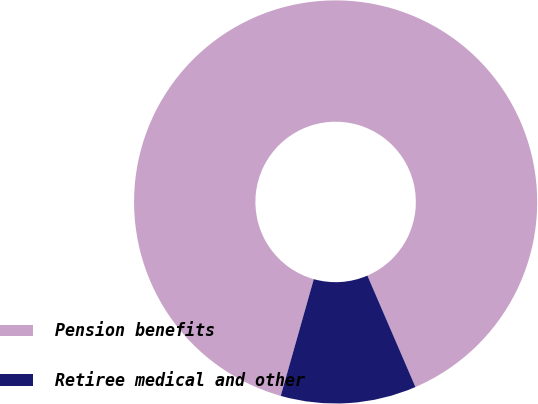<chart> <loc_0><loc_0><loc_500><loc_500><pie_chart><fcel>Pension benefits<fcel>Retiree medical and other<nl><fcel>89.13%<fcel>10.87%<nl></chart> 